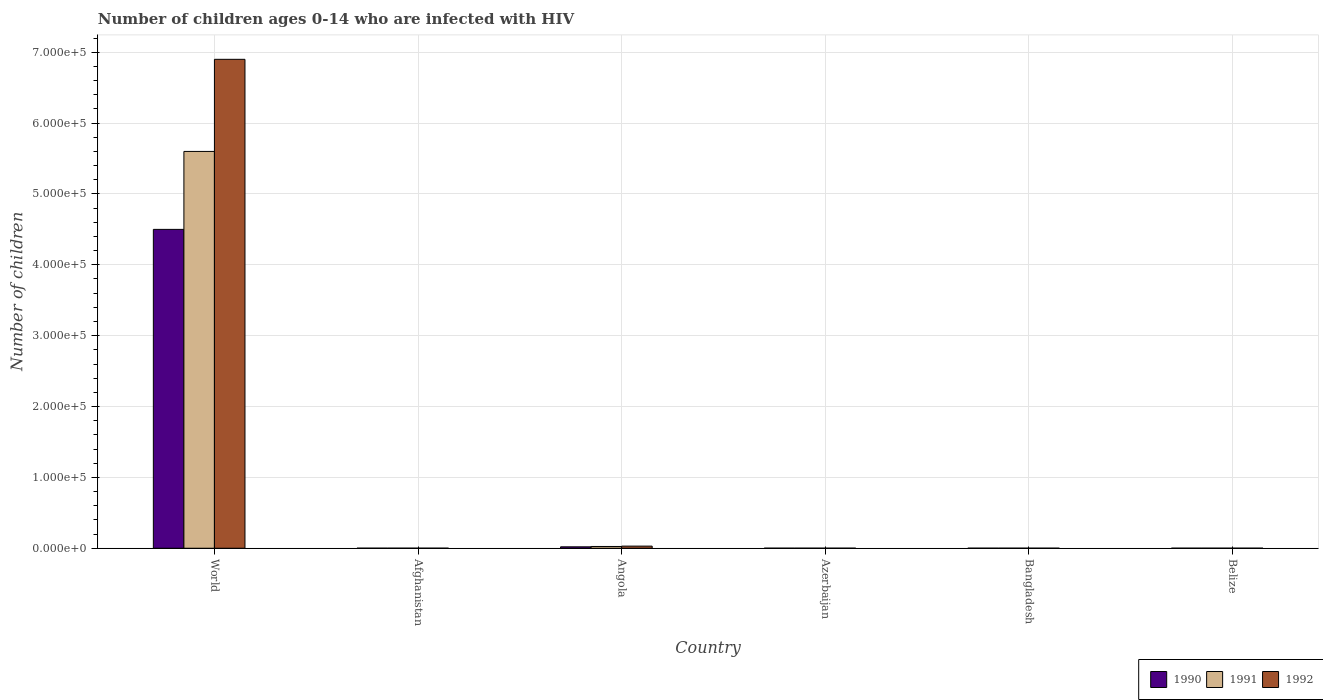Are the number of bars on each tick of the X-axis equal?
Keep it short and to the point. Yes. How many bars are there on the 3rd tick from the left?
Ensure brevity in your answer.  3. How many bars are there on the 5th tick from the right?
Your answer should be compact. 3. In how many cases, is the number of bars for a given country not equal to the number of legend labels?
Your answer should be very brief. 0. What is the number of HIV infected children in 1992 in Afghanistan?
Make the answer very short. 100. Across all countries, what is the maximum number of HIV infected children in 1990?
Offer a very short reply. 4.50e+05. Across all countries, what is the minimum number of HIV infected children in 1991?
Your answer should be compact. 100. In which country was the number of HIV infected children in 1992 minimum?
Ensure brevity in your answer.  Afghanistan. What is the total number of HIV infected children in 1992 in the graph?
Your answer should be very brief. 6.93e+05. What is the difference between the number of HIV infected children in 1990 in Bangladesh and that in Belize?
Provide a short and direct response. 0. What is the difference between the number of HIV infected children in 1991 in Angola and the number of HIV infected children in 1990 in Belize?
Give a very brief answer. 2400. What is the average number of HIV infected children in 1992 per country?
Offer a terse response. 1.16e+05. What is the difference between the number of HIV infected children of/in 1990 and number of HIV infected children of/in 1992 in World?
Your answer should be compact. -2.40e+05. In how many countries, is the number of HIV infected children in 1991 greater than 460000?
Your answer should be compact. 1. Is the difference between the number of HIV infected children in 1990 in Afghanistan and Belize greater than the difference between the number of HIV infected children in 1992 in Afghanistan and Belize?
Your response must be concise. No. What is the difference between the highest and the second highest number of HIV infected children in 1990?
Your answer should be compact. 4.50e+05. What is the difference between the highest and the lowest number of HIV infected children in 1992?
Your answer should be very brief. 6.90e+05. In how many countries, is the number of HIV infected children in 1990 greater than the average number of HIV infected children in 1990 taken over all countries?
Ensure brevity in your answer.  1. Is the sum of the number of HIV infected children in 1992 in Afghanistan and Bangladesh greater than the maximum number of HIV infected children in 1990 across all countries?
Make the answer very short. No. What does the 3rd bar from the left in Bangladesh represents?
Offer a terse response. 1992. What does the 3rd bar from the right in Angola represents?
Make the answer very short. 1990. Is it the case that in every country, the sum of the number of HIV infected children in 1990 and number of HIV infected children in 1991 is greater than the number of HIV infected children in 1992?
Offer a very short reply. Yes. How many bars are there?
Make the answer very short. 18. How many countries are there in the graph?
Make the answer very short. 6. Are the values on the major ticks of Y-axis written in scientific E-notation?
Offer a terse response. Yes. Does the graph contain grids?
Keep it short and to the point. Yes. How are the legend labels stacked?
Make the answer very short. Horizontal. What is the title of the graph?
Offer a terse response. Number of children ages 0-14 who are infected with HIV. Does "1980" appear as one of the legend labels in the graph?
Your answer should be very brief. No. What is the label or title of the Y-axis?
Make the answer very short. Number of children. What is the Number of children of 1990 in World?
Provide a short and direct response. 4.50e+05. What is the Number of children in 1991 in World?
Make the answer very short. 5.60e+05. What is the Number of children in 1992 in World?
Your answer should be very brief. 6.90e+05. What is the Number of children in 1990 in Afghanistan?
Keep it short and to the point. 100. What is the Number of children in 1991 in Afghanistan?
Your answer should be very brief. 100. What is the Number of children in 1992 in Afghanistan?
Ensure brevity in your answer.  100. What is the Number of children in 1991 in Angola?
Offer a very short reply. 2500. What is the Number of children of 1992 in Angola?
Offer a very short reply. 3000. What is the Number of children of 1992 in Azerbaijan?
Provide a short and direct response. 100. What is the Number of children in 1990 in Bangladesh?
Make the answer very short. 100. What is the Number of children in 1992 in Bangladesh?
Your answer should be very brief. 100. What is the Number of children of 1990 in Belize?
Make the answer very short. 100. What is the Number of children of 1992 in Belize?
Provide a succinct answer. 100. Across all countries, what is the maximum Number of children of 1990?
Make the answer very short. 4.50e+05. Across all countries, what is the maximum Number of children in 1991?
Provide a succinct answer. 5.60e+05. Across all countries, what is the maximum Number of children of 1992?
Your answer should be very brief. 6.90e+05. Across all countries, what is the minimum Number of children in 1990?
Provide a short and direct response. 100. Across all countries, what is the minimum Number of children in 1991?
Offer a terse response. 100. Across all countries, what is the minimum Number of children of 1992?
Your response must be concise. 100. What is the total Number of children in 1990 in the graph?
Make the answer very short. 4.52e+05. What is the total Number of children of 1991 in the graph?
Offer a terse response. 5.63e+05. What is the total Number of children in 1992 in the graph?
Make the answer very short. 6.93e+05. What is the difference between the Number of children in 1990 in World and that in Afghanistan?
Provide a succinct answer. 4.50e+05. What is the difference between the Number of children of 1991 in World and that in Afghanistan?
Offer a very short reply. 5.60e+05. What is the difference between the Number of children of 1992 in World and that in Afghanistan?
Ensure brevity in your answer.  6.90e+05. What is the difference between the Number of children in 1990 in World and that in Angola?
Your answer should be very brief. 4.48e+05. What is the difference between the Number of children of 1991 in World and that in Angola?
Your answer should be very brief. 5.58e+05. What is the difference between the Number of children in 1992 in World and that in Angola?
Ensure brevity in your answer.  6.87e+05. What is the difference between the Number of children in 1990 in World and that in Azerbaijan?
Provide a short and direct response. 4.50e+05. What is the difference between the Number of children of 1991 in World and that in Azerbaijan?
Ensure brevity in your answer.  5.60e+05. What is the difference between the Number of children in 1992 in World and that in Azerbaijan?
Your answer should be compact. 6.90e+05. What is the difference between the Number of children in 1990 in World and that in Bangladesh?
Your response must be concise. 4.50e+05. What is the difference between the Number of children in 1991 in World and that in Bangladesh?
Your response must be concise. 5.60e+05. What is the difference between the Number of children in 1992 in World and that in Bangladesh?
Provide a succinct answer. 6.90e+05. What is the difference between the Number of children in 1990 in World and that in Belize?
Keep it short and to the point. 4.50e+05. What is the difference between the Number of children of 1991 in World and that in Belize?
Offer a very short reply. 5.60e+05. What is the difference between the Number of children of 1992 in World and that in Belize?
Offer a terse response. 6.90e+05. What is the difference between the Number of children in 1990 in Afghanistan and that in Angola?
Your answer should be compact. -1900. What is the difference between the Number of children of 1991 in Afghanistan and that in Angola?
Offer a very short reply. -2400. What is the difference between the Number of children in 1992 in Afghanistan and that in Angola?
Offer a terse response. -2900. What is the difference between the Number of children of 1990 in Afghanistan and that in Azerbaijan?
Offer a terse response. 0. What is the difference between the Number of children in 1991 in Afghanistan and that in Azerbaijan?
Ensure brevity in your answer.  0. What is the difference between the Number of children in 1991 in Afghanistan and that in Bangladesh?
Keep it short and to the point. 0. What is the difference between the Number of children in 1990 in Afghanistan and that in Belize?
Make the answer very short. 0. What is the difference between the Number of children of 1991 in Afghanistan and that in Belize?
Offer a terse response. 0. What is the difference between the Number of children in 1992 in Afghanistan and that in Belize?
Make the answer very short. 0. What is the difference between the Number of children in 1990 in Angola and that in Azerbaijan?
Give a very brief answer. 1900. What is the difference between the Number of children in 1991 in Angola and that in Azerbaijan?
Your response must be concise. 2400. What is the difference between the Number of children in 1992 in Angola and that in Azerbaijan?
Offer a terse response. 2900. What is the difference between the Number of children in 1990 in Angola and that in Bangladesh?
Provide a short and direct response. 1900. What is the difference between the Number of children in 1991 in Angola and that in Bangladesh?
Offer a very short reply. 2400. What is the difference between the Number of children of 1992 in Angola and that in Bangladesh?
Your answer should be very brief. 2900. What is the difference between the Number of children in 1990 in Angola and that in Belize?
Offer a terse response. 1900. What is the difference between the Number of children in 1991 in Angola and that in Belize?
Offer a very short reply. 2400. What is the difference between the Number of children in 1992 in Angola and that in Belize?
Keep it short and to the point. 2900. What is the difference between the Number of children in 1990 in Azerbaijan and that in Bangladesh?
Provide a short and direct response. 0. What is the difference between the Number of children of 1992 in Azerbaijan and that in Bangladesh?
Ensure brevity in your answer.  0. What is the difference between the Number of children of 1990 in Bangladesh and that in Belize?
Your answer should be compact. 0. What is the difference between the Number of children of 1991 in Bangladesh and that in Belize?
Provide a succinct answer. 0. What is the difference between the Number of children of 1990 in World and the Number of children of 1991 in Afghanistan?
Your answer should be compact. 4.50e+05. What is the difference between the Number of children of 1990 in World and the Number of children of 1992 in Afghanistan?
Keep it short and to the point. 4.50e+05. What is the difference between the Number of children of 1991 in World and the Number of children of 1992 in Afghanistan?
Offer a terse response. 5.60e+05. What is the difference between the Number of children in 1990 in World and the Number of children in 1991 in Angola?
Offer a terse response. 4.48e+05. What is the difference between the Number of children in 1990 in World and the Number of children in 1992 in Angola?
Provide a succinct answer. 4.47e+05. What is the difference between the Number of children in 1991 in World and the Number of children in 1992 in Angola?
Keep it short and to the point. 5.57e+05. What is the difference between the Number of children in 1990 in World and the Number of children in 1991 in Azerbaijan?
Your answer should be compact. 4.50e+05. What is the difference between the Number of children of 1990 in World and the Number of children of 1992 in Azerbaijan?
Your answer should be very brief. 4.50e+05. What is the difference between the Number of children in 1991 in World and the Number of children in 1992 in Azerbaijan?
Provide a succinct answer. 5.60e+05. What is the difference between the Number of children of 1990 in World and the Number of children of 1991 in Bangladesh?
Give a very brief answer. 4.50e+05. What is the difference between the Number of children of 1990 in World and the Number of children of 1992 in Bangladesh?
Make the answer very short. 4.50e+05. What is the difference between the Number of children in 1991 in World and the Number of children in 1992 in Bangladesh?
Offer a terse response. 5.60e+05. What is the difference between the Number of children in 1990 in World and the Number of children in 1991 in Belize?
Ensure brevity in your answer.  4.50e+05. What is the difference between the Number of children in 1990 in World and the Number of children in 1992 in Belize?
Offer a terse response. 4.50e+05. What is the difference between the Number of children in 1991 in World and the Number of children in 1992 in Belize?
Provide a short and direct response. 5.60e+05. What is the difference between the Number of children in 1990 in Afghanistan and the Number of children in 1991 in Angola?
Provide a succinct answer. -2400. What is the difference between the Number of children in 1990 in Afghanistan and the Number of children in 1992 in Angola?
Your answer should be compact. -2900. What is the difference between the Number of children of 1991 in Afghanistan and the Number of children of 1992 in Angola?
Provide a succinct answer. -2900. What is the difference between the Number of children of 1990 in Afghanistan and the Number of children of 1992 in Azerbaijan?
Your answer should be compact. 0. What is the difference between the Number of children of 1991 in Afghanistan and the Number of children of 1992 in Azerbaijan?
Offer a very short reply. 0. What is the difference between the Number of children in 1990 in Angola and the Number of children in 1991 in Azerbaijan?
Make the answer very short. 1900. What is the difference between the Number of children of 1990 in Angola and the Number of children of 1992 in Azerbaijan?
Ensure brevity in your answer.  1900. What is the difference between the Number of children of 1991 in Angola and the Number of children of 1992 in Azerbaijan?
Ensure brevity in your answer.  2400. What is the difference between the Number of children in 1990 in Angola and the Number of children in 1991 in Bangladesh?
Offer a very short reply. 1900. What is the difference between the Number of children in 1990 in Angola and the Number of children in 1992 in Bangladesh?
Ensure brevity in your answer.  1900. What is the difference between the Number of children in 1991 in Angola and the Number of children in 1992 in Bangladesh?
Offer a very short reply. 2400. What is the difference between the Number of children in 1990 in Angola and the Number of children in 1991 in Belize?
Your answer should be very brief. 1900. What is the difference between the Number of children of 1990 in Angola and the Number of children of 1992 in Belize?
Offer a very short reply. 1900. What is the difference between the Number of children of 1991 in Angola and the Number of children of 1992 in Belize?
Your response must be concise. 2400. What is the difference between the Number of children of 1990 in Azerbaijan and the Number of children of 1992 in Bangladesh?
Your answer should be compact. 0. What is the difference between the Number of children in 1990 in Azerbaijan and the Number of children in 1991 in Belize?
Give a very brief answer. 0. What is the difference between the Number of children of 1990 in Bangladesh and the Number of children of 1992 in Belize?
Offer a terse response. 0. What is the difference between the Number of children of 1991 in Bangladesh and the Number of children of 1992 in Belize?
Offer a very short reply. 0. What is the average Number of children of 1990 per country?
Offer a terse response. 7.54e+04. What is the average Number of children of 1991 per country?
Provide a succinct answer. 9.38e+04. What is the average Number of children of 1992 per country?
Your answer should be compact. 1.16e+05. What is the difference between the Number of children of 1990 and Number of children of 1992 in World?
Your answer should be very brief. -2.40e+05. What is the difference between the Number of children in 1990 and Number of children in 1991 in Afghanistan?
Make the answer very short. 0. What is the difference between the Number of children of 1991 and Number of children of 1992 in Afghanistan?
Offer a terse response. 0. What is the difference between the Number of children in 1990 and Number of children in 1991 in Angola?
Your answer should be compact. -500. What is the difference between the Number of children of 1990 and Number of children of 1992 in Angola?
Your response must be concise. -1000. What is the difference between the Number of children in 1991 and Number of children in 1992 in Angola?
Make the answer very short. -500. What is the difference between the Number of children in 1991 and Number of children in 1992 in Bangladesh?
Give a very brief answer. 0. What is the difference between the Number of children of 1990 and Number of children of 1991 in Belize?
Your answer should be compact. 0. What is the difference between the Number of children of 1990 and Number of children of 1992 in Belize?
Provide a short and direct response. 0. What is the difference between the Number of children in 1991 and Number of children in 1992 in Belize?
Your answer should be very brief. 0. What is the ratio of the Number of children in 1990 in World to that in Afghanistan?
Keep it short and to the point. 4500. What is the ratio of the Number of children in 1991 in World to that in Afghanistan?
Offer a very short reply. 5600. What is the ratio of the Number of children of 1992 in World to that in Afghanistan?
Provide a succinct answer. 6900. What is the ratio of the Number of children of 1990 in World to that in Angola?
Your answer should be very brief. 225. What is the ratio of the Number of children of 1991 in World to that in Angola?
Your answer should be very brief. 224. What is the ratio of the Number of children in 1992 in World to that in Angola?
Make the answer very short. 230. What is the ratio of the Number of children in 1990 in World to that in Azerbaijan?
Make the answer very short. 4500. What is the ratio of the Number of children in 1991 in World to that in Azerbaijan?
Your answer should be very brief. 5600. What is the ratio of the Number of children in 1992 in World to that in Azerbaijan?
Keep it short and to the point. 6900. What is the ratio of the Number of children of 1990 in World to that in Bangladesh?
Your answer should be very brief. 4500. What is the ratio of the Number of children of 1991 in World to that in Bangladesh?
Keep it short and to the point. 5600. What is the ratio of the Number of children of 1992 in World to that in Bangladesh?
Your answer should be very brief. 6900. What is the ratio of the Number of children in 1990 in World to that in Belize?
Make the answer very short. 4500. What is the ratio of the Number of children in 1991 in World to that in Belize?
Make the answer very short. 5600. What is the ratio of the Number of children of 1992 in World to that in Belize?
Your answer should be very brief. 6900. What is the ratio of the Number of children of 1990 in Afghanistan to that in Angola?
Give a very brief answer. 0.05. What is the ratio of the Number of children in 1991 in Afghanistan to that in Angola?
Your answer should be very brief. 0.04. What is the ratio of the Number of children in 1992 in Afghanistan to that in Angola?
Your answer should be very brief. 0.03. What is the ratio of the Number of children in 1991 in Afghanistan to that in Azerbaijan?
Offer a very short reply. 1. What is the ratio of the Number of children of 1990 in Afghanistan to that in Bangladesh?
Ensure brevity in your answer.  1. What is the ratio of the Number of children in 1991 in Afghanistan to that in Bangladesh?
Your response must be concise. 1. What is the ratio of the Number of children in 1991 in Afghanistan to that in Belize?
Offer a terse response. 1. What is the ratio of the Number of children in 1992 in Afghanistan to that in Belize?
Make the answer very short. 1. What is the ratio of the Number of children in 1992 in Angola to that in Bangladesh?
Your answer should be compact. 30. What is the ratio of the Number of children of 1990 in Angola to that in Belize?
Offer a terse response. 20. What is the ratio of the Number of children of 1991 in Angola to that in Belize?
Give a very brief answer. 25. What is the ratio of the Number of children in 1990 in Azerbaijan to that in Bangladesh?
Provide a succinct answer. 1. What is the ratio of the Number of children in 1991 in Azerbaijan to that in Bangladesh?
Keep it short and to the point. 1. What is the ratio of the Number of children in 1992 in Azerbaijan to that in Bangladesh?
Ensure brevity in your answer.  1. What is the ratio of the Number of children of 1991 in Azerbaijan to that in Belize?
Your answer should be very brief. 1. What is the ratio of the Number of children in 1991 in Bangladesh to that in Belize?
Offer a very short reply. 1. What is the difference between the highest and the second highest Number of children of 1990?
Your answer should be compact. 4.48e+05. What is the difference between the highest and the second highest Number of children of 1991?
Your answer should be very brief. 5.58e+05. What is the difference between the highest and the second highest Number of children in 1992?
Give a very brief answer. 6.87e+05. What is the difference between the highest and the lowest Number of children in 1990?
Give a very brief answer. 4.50e+05. What is the difference between the highest and the lowest Number of children in 1991?
Ensure brevity in your answer.  5.60e+05. What is the difference between the highest and the lowest Number of children in 1992?
Provide a succinct answer. 6.90e+05. 